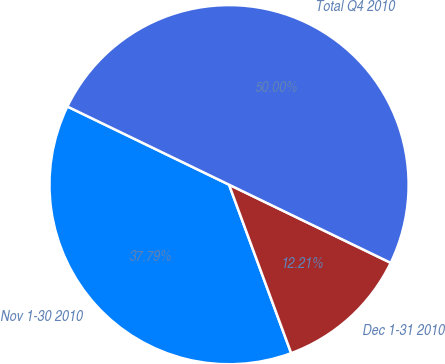<chart> <loc_0><loc_0><loc_500><loc_500><pie_chart><fcel>Nov 1-30 2010<fcel>Dec 1-31 2010<fcel>Total Q4 2010<nl><fcel>37.79%<fcel>12.21%<fcel>50.0%<nl></chart> 